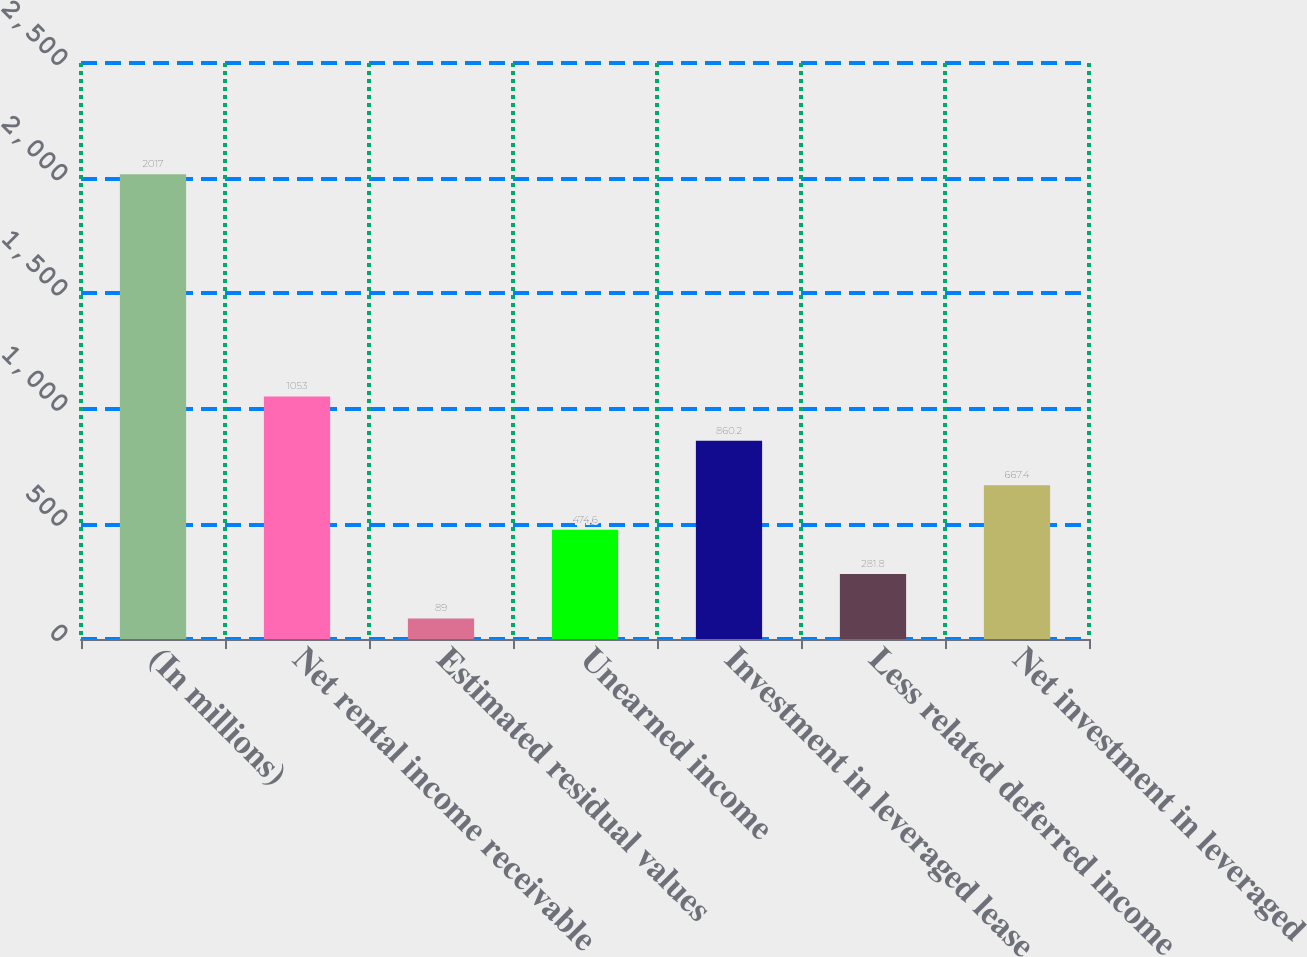<chart> <loc_0><loc_0><loc_500><loc_500><bar_chart><fcel>(In millions)<fcel>Net rental income receivable<fcel>Estimated residual values<fcel>Unearned income<fcel>Investment in leveraged lease<fcel>Less related deferred income<fcel>Net investment in leveraged<nl><fcel>2017<fcel>1053<fcel>89<fcel>474.6<fcel>860.2<fcel>281.8<fcel>667.4<nl></chart> 